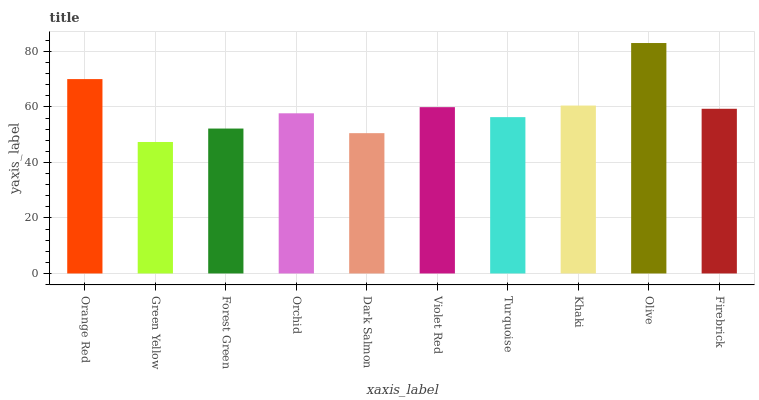Is Green Yellow the minimum?
Answer yes or no. Yes. Is Olive the maximum?
Answer yes or no. Yes. Is Forest Green the minimum?
Answer yes or no. No. Is Forest Green the maximum?
Answer yes or no. No. Is Forest Green greater than Green Yellow?
Answer yes or no. Yes. Is Green Yellow less than Forest Green?
Answer yes or no. Yes. Is Green Yellow greater than Forest Green?
Answer yes or no. No. Is Forest Green less than Green Yellow?
Answer yes or no. No. Is Firebrick the high median?
Answer yes or no. Yes. Is Orchid the low median?
Answer yes or no. Yes. Is Olive the high median?
Answer yes or no. No. Is Turquoise the low median?
Answer yes or no. No. 